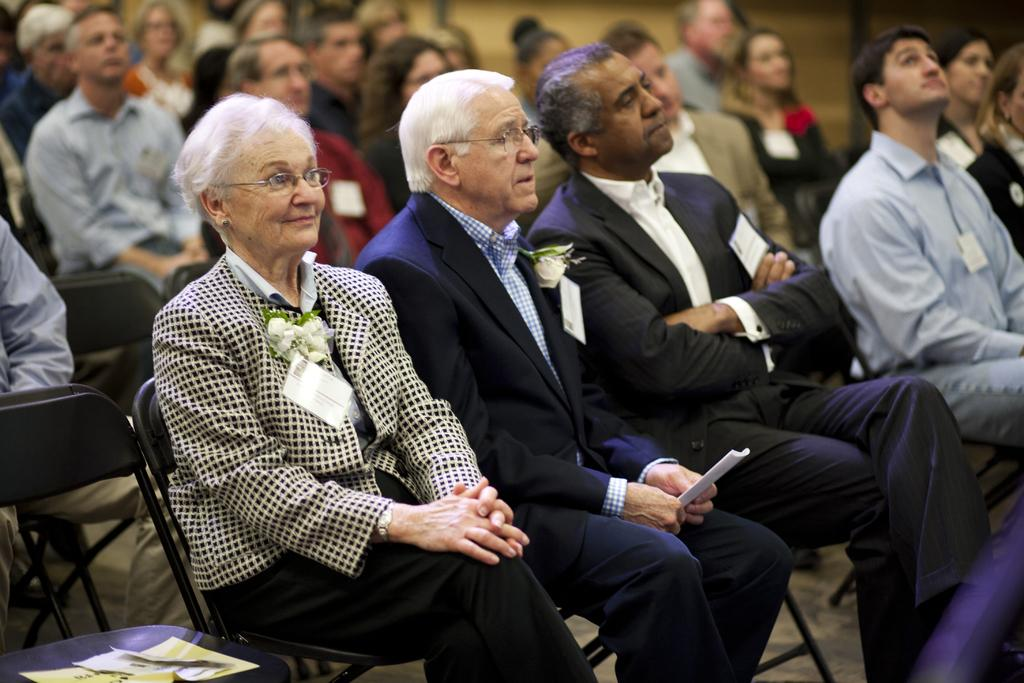What is the main subject of the image? The main subject of the image is a group of people. What are the people doing in the image? The people are sitting on chairs in the image. Are there any objects placed on the chairs? Yes, there are papers placed on the chairs. What can be observed about the people's clothing in the image? The people are wearing clothes with badges attached. What type of boundary can be seen in the image? There is no boundary present in the image. Can you identify the company the people in the image are working for? The image does not provide any information about the company the people are working for. 